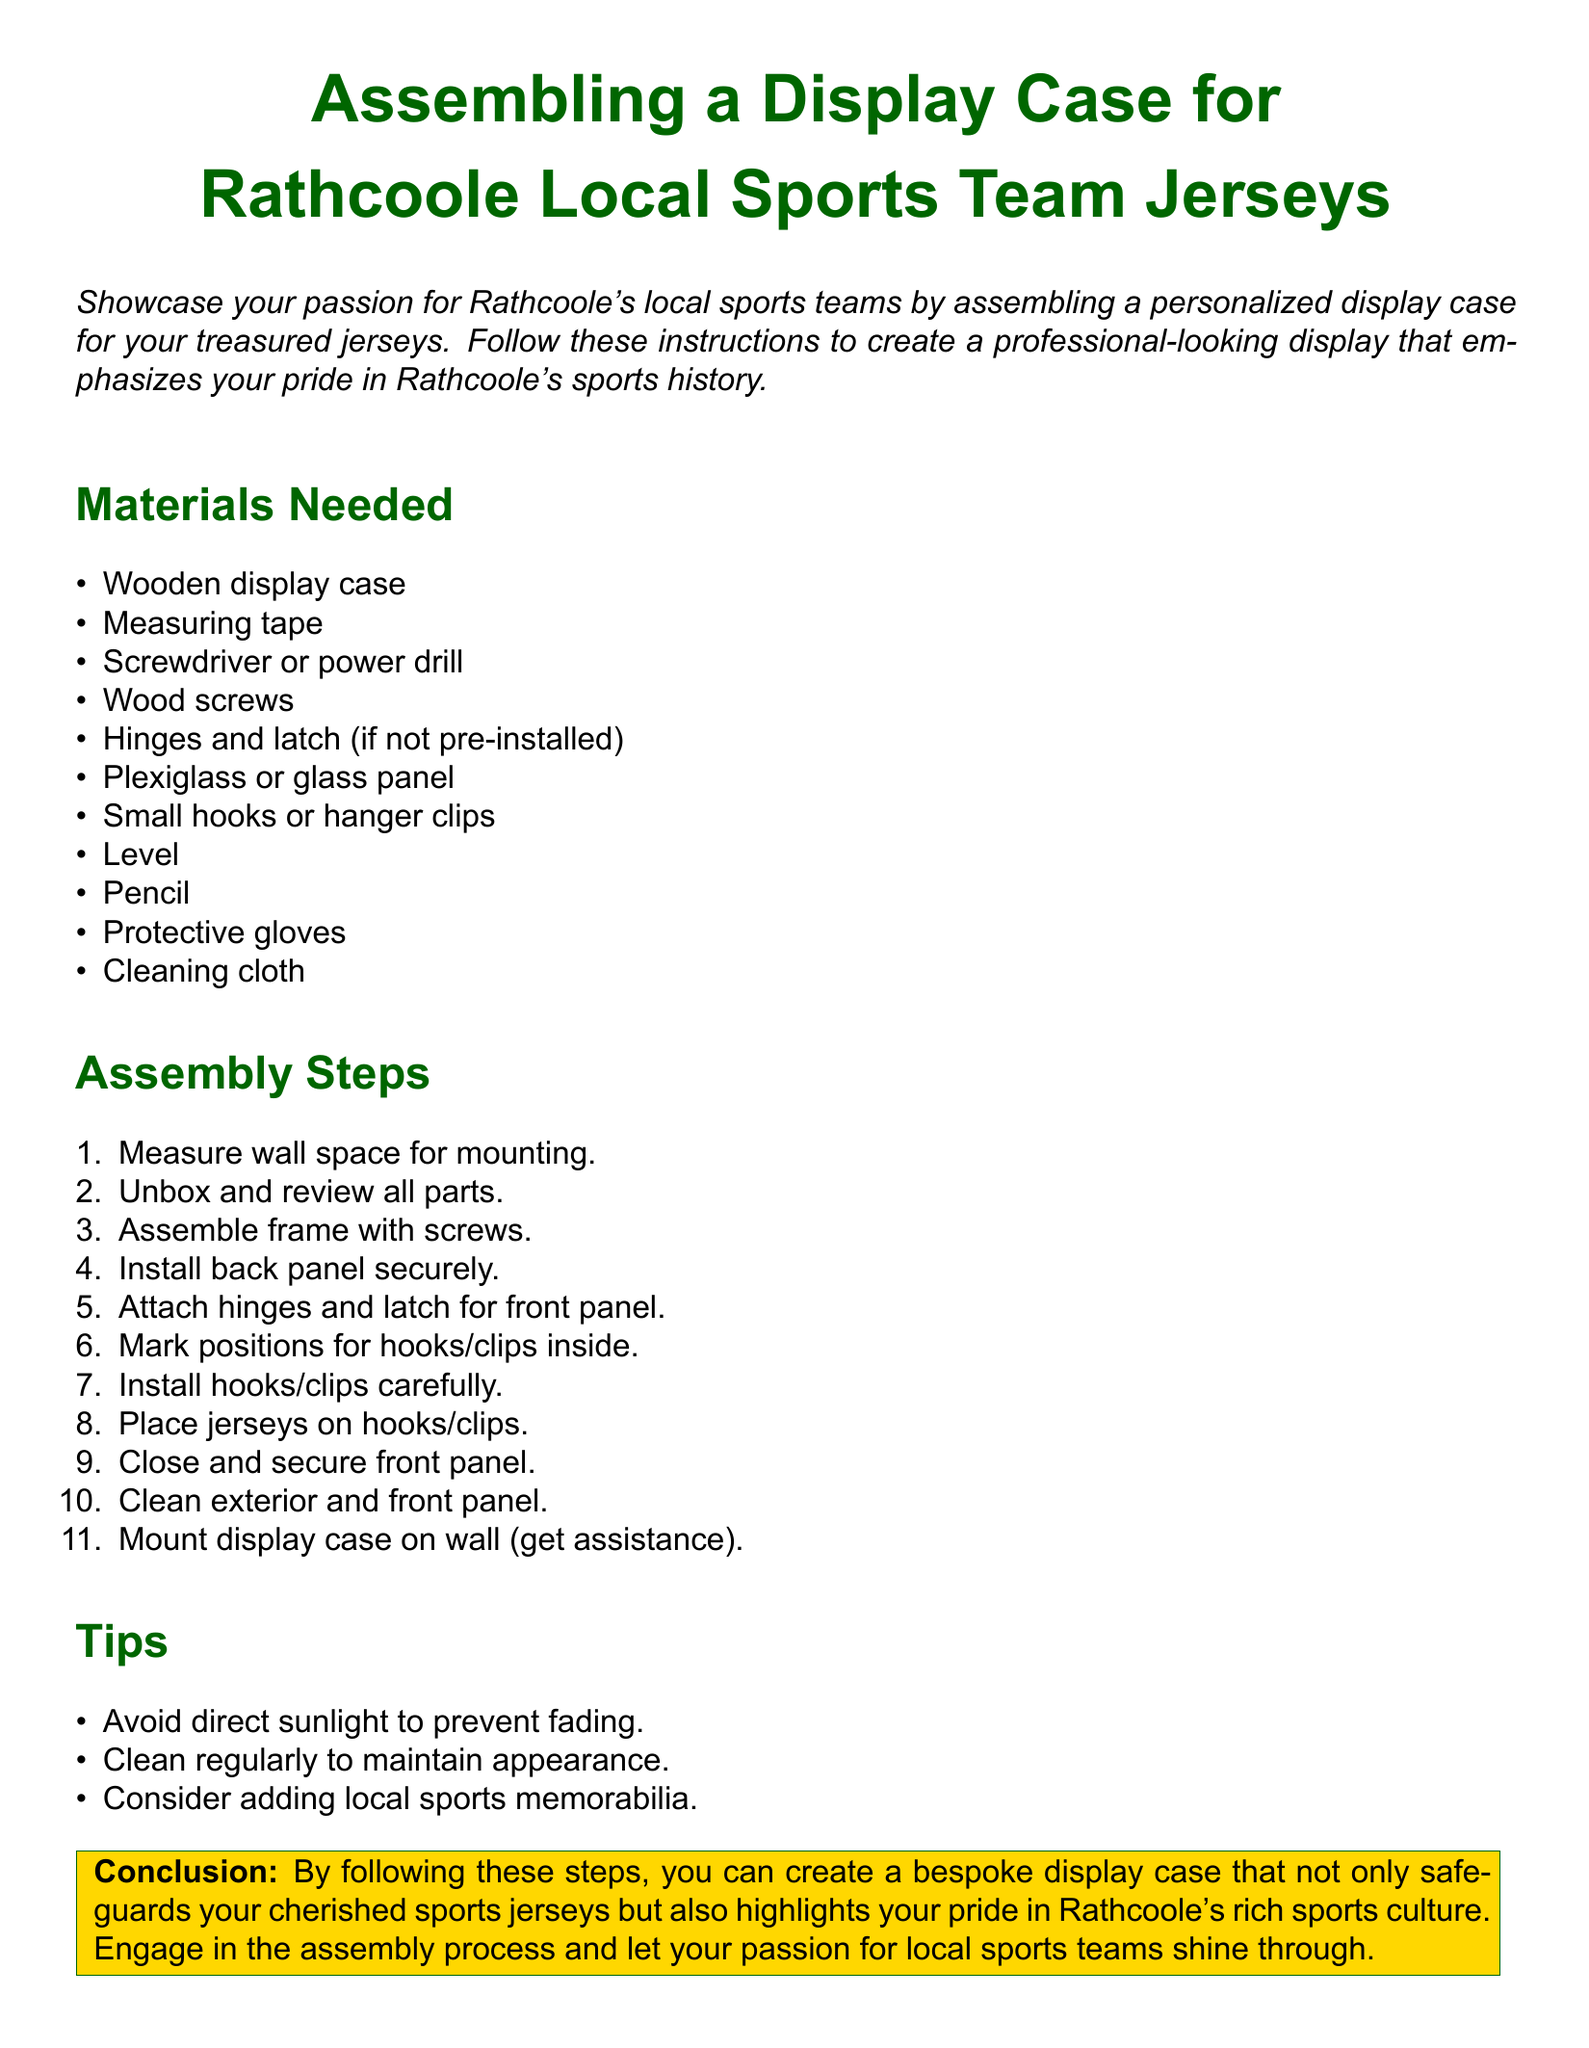What is the title of the document? The title is the main heading of the document that indicates its purpose, which is about assembling a display case for local sports team jerseys.
Answer: Assembling a Display Case for Rathcoole Local Sports Team Jerseys How many materials are listed in the document? The materials needed section consists of items necessary for assembling the display case, which can be counted directly in the document list.
Answer: 11 What should you use to secure the front panel? The assembly steps mention a specific item used to attach the front panel to the case for security.
Answer: Hinges and latch What is the first step in the assembly process? The first step listed in the assembly steps outlines the initial action to prepare for mounting the display case.
Answer: Measure wall space for mounting What color is the background of the title? The title has a specific color that matches the theme of the document and is mentioned in the document's styles.
Answer: Rathcoole green What should you avoid to prevent fading? The tips section advises on what to avoid while displaying jerseys to maintain their appearance.
Answer: Direct sunlight How should you clean the front panel? The assembly steps recommend an action to maintain the cleanliness and appearance of the display case.
Answer: Clean exterior and front panel What type of gloves are recommended? The materials needed section includes a specific type of safety gear suggested for use during assembly.
Answer: Protective gloves What is suggested to add with the jerseys? The tips section presents an additional recommendation for enhancing the display case alongside the jerseys.
Answer: Local sports memorabilia 